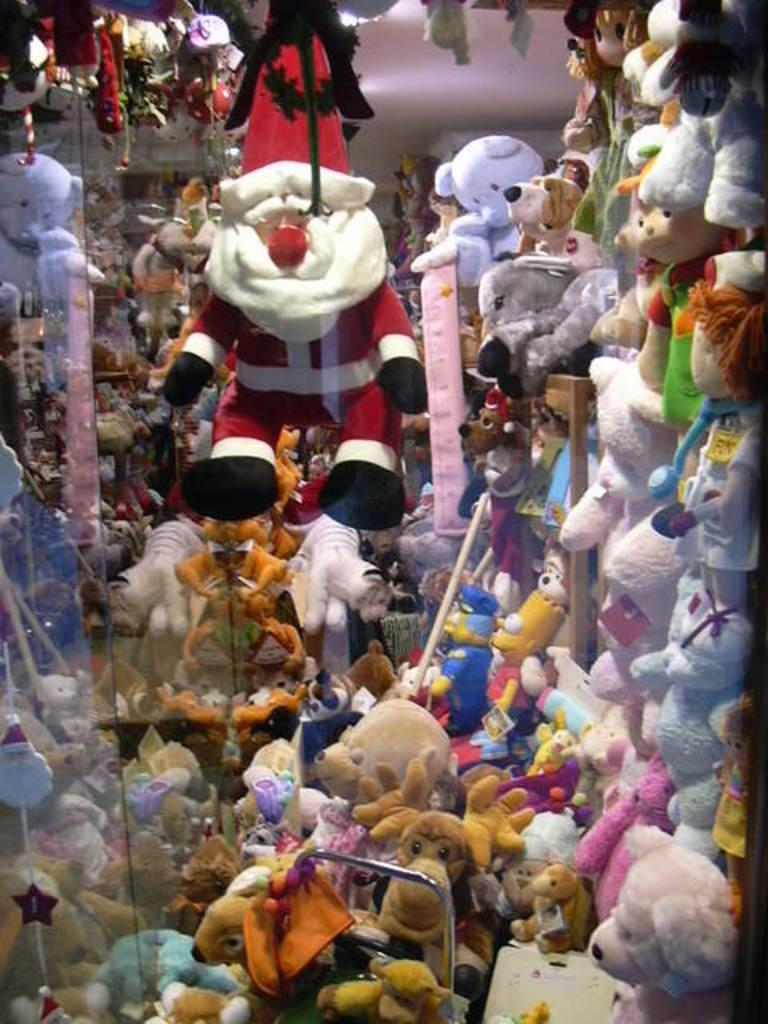What type of doll is the main subject in the image? There is a doll of Christmas grand father in the image. What other types of toys are present in the image? There are many teddy bears and other dolls in the image. Can you see a stranger holding a rifle in the image? No, there is no stranger or rifle present in the image. The image only features toys, including the Christmas grand father doll, teddy bears, and other dolls. 